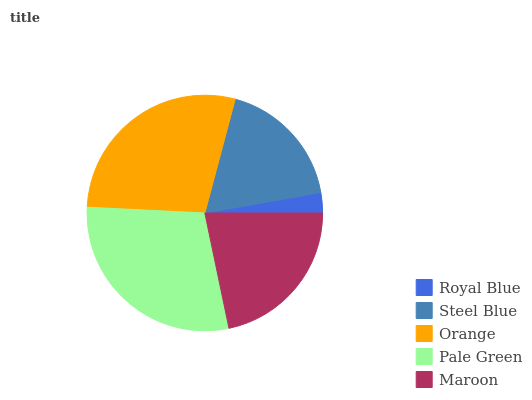Is Royal Blue the minimum?
Answer yes or no. Yes. Is Pale Green the maximum?
Answer yes or no. Yes. Is Steel Blue the minimum?
Answer yes or no. No. Is Steel Blue the maximum?
Answer yes or no. No. Is Steel Blue greater than Royal Blue?
Answer yes or no. Yes. Is Royal Blue less than Steel Blue?
Answer yes or no. Yes. Is Royal Blue greater than Steel Blue?
Answer yes or no. No. Is Steel Blue less than Royal Blue?
Answer yes or no. No. Is Maroon the high median?
Answer yes or no. Yes. Is Maroon the low median?
Answer yes or no. Yes. Is Steel Blue the high median?
Answer yes or no. No. Is Orange the low median?
Answer yes or no. No. 